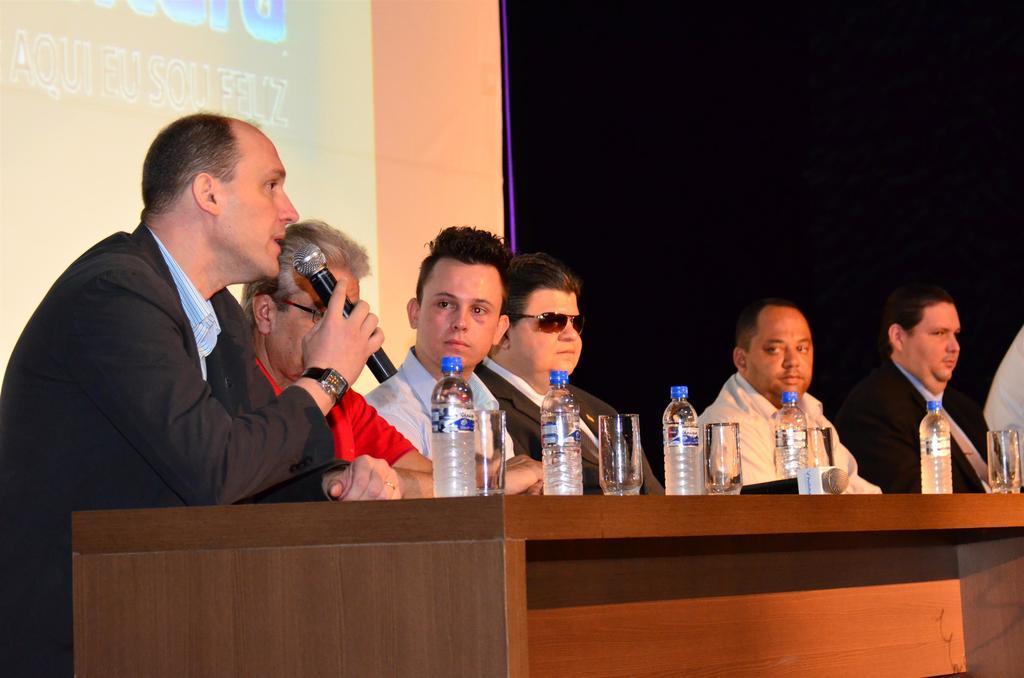Describe this image in one or two sentences. In this image there is a table on that table there are water bottles, glasses, behind the table there are few people sitting on chairs, one person is holding a mic in his hand, in the background there is a banner on that banner there is some text. 